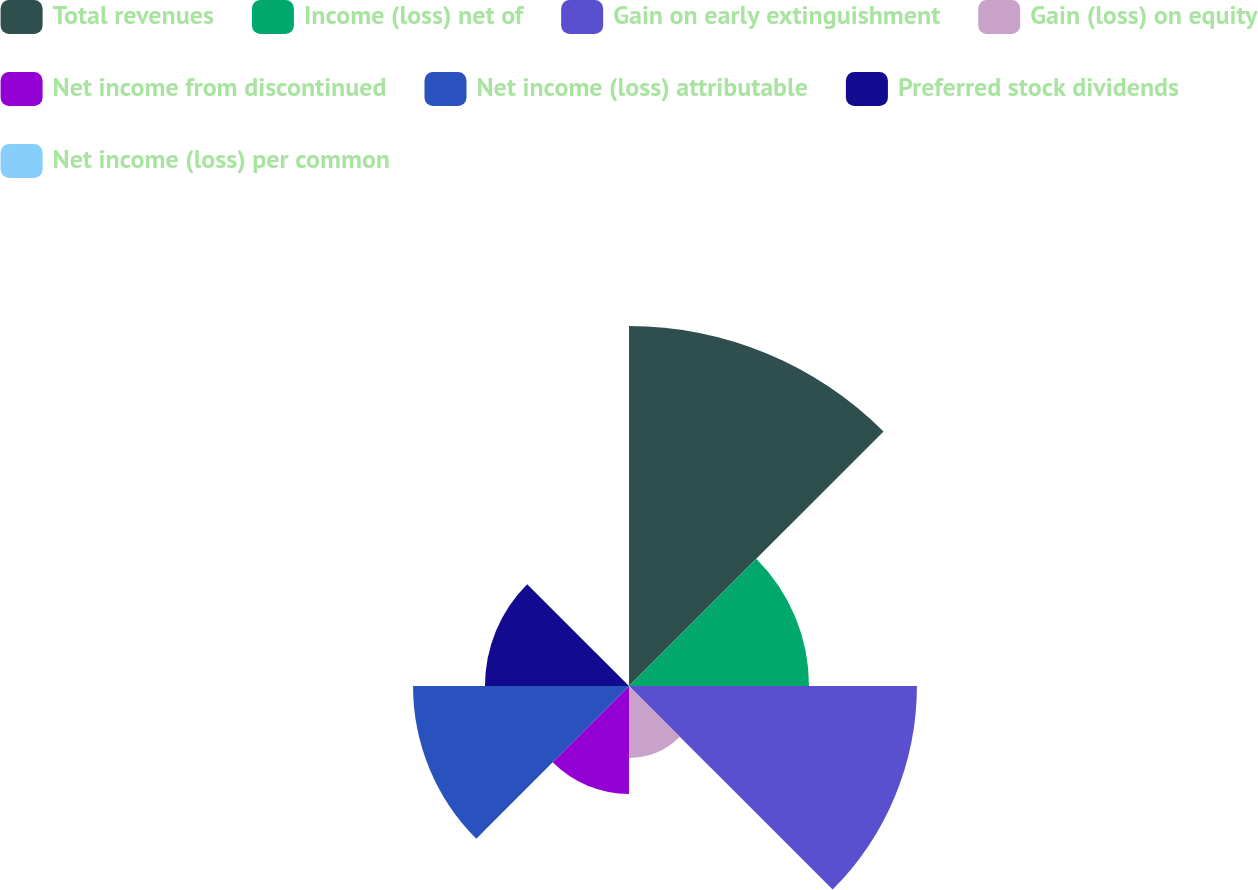Convert chart to OTSL. <chart><loc_0><loc_0><loc_500><loc_500><pie_chart><fcel>Total revenues<fcel>Income (loss) net of<fcel>Gain on early extinguishment<fcel>Gain (loss) on equity<fcel>Net income from discontinued<fcel>Net income (loss) attributable<fcel>Preferred stock dividends<fcel>Net income (loss) per common<nl><fcel>26.32%<fcel>13.16%<fcel>21.05%<fcel>5.26%<fcel>7.89%<fcel>15.79%<fcel>10.53%<fcel>0.0%<nl></chart> 